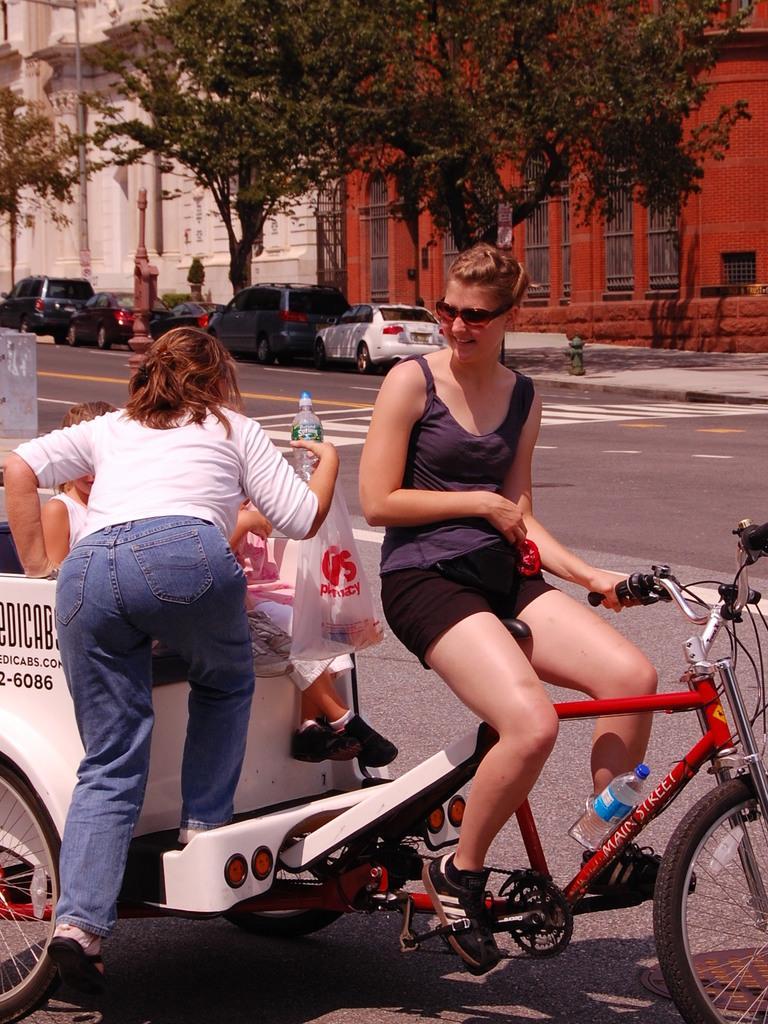Could you give a brief overview of what you see in this image? In the image there is a woman riding bicycle with a wagon attached behind it and two kids and a woman on it, in the back there are buildings with trees and cars in front of it on the road. 